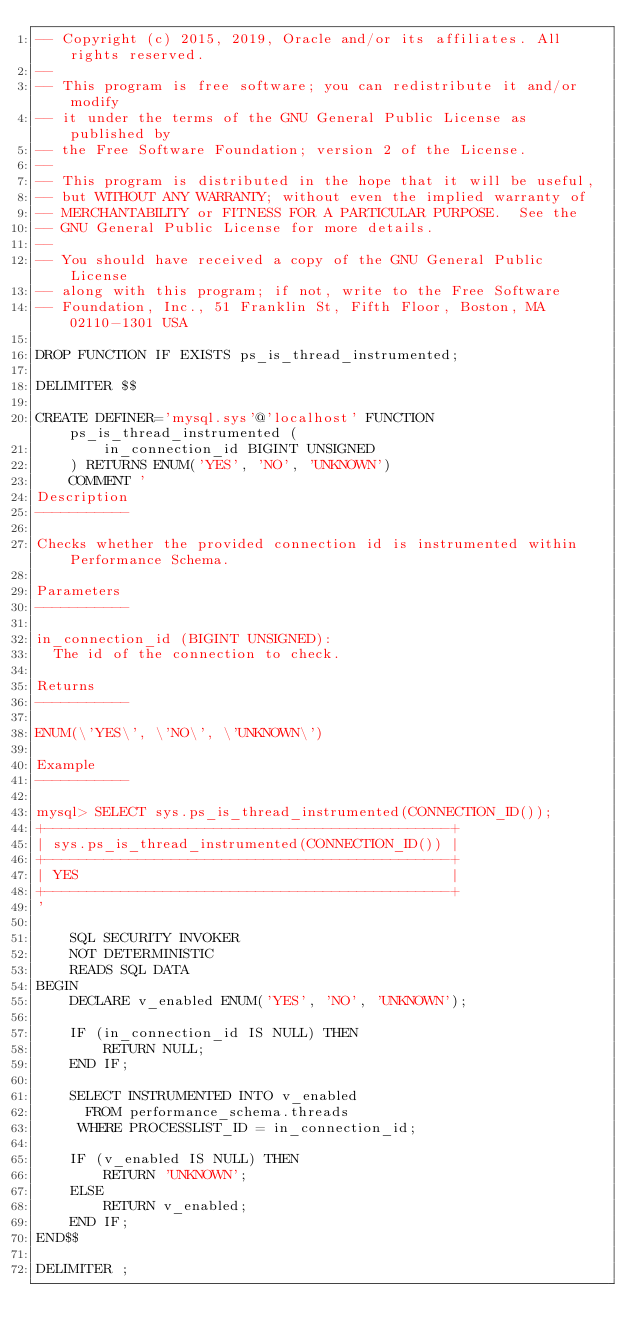<code> <loc_0><loc_0><loc_500><loc_500><_SQL_>-- Copyright (c) 2015, 2019, Oracle and/or its affiliates. All rights reserved.
--
-- This program is free software; you can redistribute it and/or modify
-- it under the terms of the GNU General Public License as published by
-- the Free Software Foundation; version 2 of the License.
--
-- This program is distributed in the hope that it will be useful,
-- but WITHOUT ANY WARRANTY; without even the implied warranty of
-- MERCHANTABILITY or FITNESS FOR A PARTICULAR PURPOSE.  See the
-- GNU General Public License for more details.
--
-- You should have received a copy of the GNU General Public License
-- along with this program; if not, write to the Free Software
-- Foundation, Inc., 51 Franklin St, Fifth Floor, Boston, MA 02110-1301 USA

DROP FUNCTION IF EXISTS ps_is_thread_instrumented;

DELIMITER $$

CREATE DEFINER='mysql.sys'@'localhost' FUNCTION ps_is_thread_instrumented (
        in_connection_id BIGINT UNSIGNED
    ) RETURNS ENUM('YES', 'NO', 'UNKNOWN')
    COMMENT '
Description
-----------

Checks whether the provided connection id is instrumented within Performance Schema.

Parameters
-----------

in_connection_id (BIGINT UNSIGNED):
  The id of the connection to check.

Returns
-----------

ENUM(\'YES\', \'NO\', \'UNKNOWN\')

Example
-----------

mysql> SELECT sys.ps_is_thread_instrumented(CONNECTION_ID());
+------------------------------------------------+
| sys.ps_is_thread_instrumented(CONNECTION_ID()) |
+------------------------------------------------+
| YES                                            |
+------------------------------------------------+
'

    SQL SECURITY INVOKER
    NOT DETERMINISTIC
    READS SQL DATA
BEGIN
    DECLARE v_enabled ENUM('YES', 'NO', 'UNKNOWN');

    IF (in_connection_id IS NULL) THEN
        RETURN NULL;
    END IF;

    SELECT INSTRUMENTED INTO v_enabled
      FROM performance_schema.threads 
     WHERE PROCESSLIST_ID = in_connection_id;

    IF (v_enabled IS NULL) THEN
        RETURN 'UNKNOWN';
    ELSE
        RETURN v_enabled;
    END IF;
END$$

DELIMITER ;
</code> 